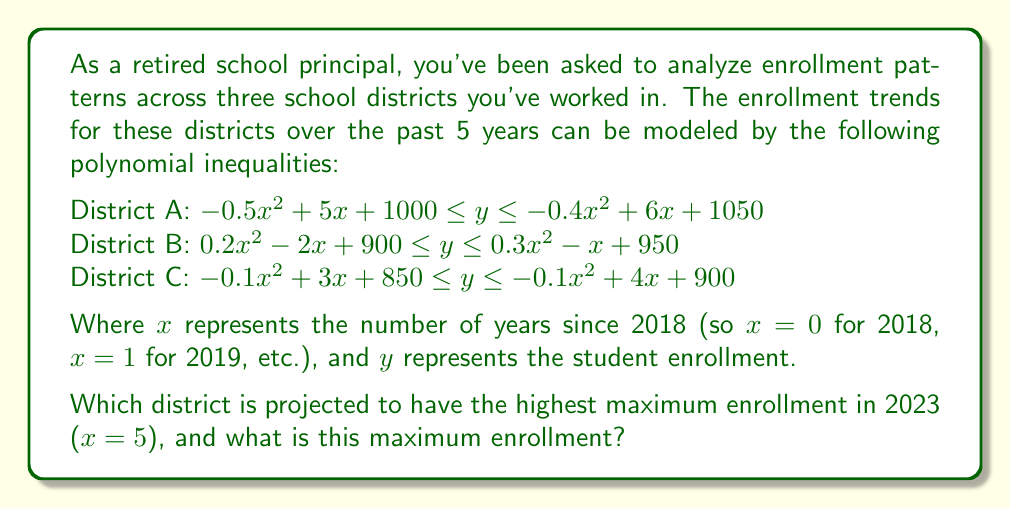Could you help me with this problem? To solve this problem, we need to evaluate the upper bound of each inequality at $x = 5$, as this will give us the maximum possible enrollment for each district in 2023.

For District A:
Upper bound: $y = -0.4x^2 + 6x + 1050$
At $x = 5$: $y = -0.4(5)^2 + 6(5) + 1050 = -10 + 30 + 1050 = 1070$

For District B:
Upper bound: $y = 0.3x^2 - x + 950$
At $x = 5$: $y = 0.3(5)^2 - 5 + 950 = 7.5 - 5 + 950 = 952.5$

For District C:
Upper bound: $y = -0.1x^2 + 4x + 900$
At $x = 5$: $y = -0.1(5)^2 + 4(5) + 900 = -2.5 + 20 + 900 = 917.5$

Comparing these results:
District A: 1070
District B: 952.5
District C: 917.5

We can see that District A has the highest projected maximum enrollment in 2023.
Answer: District A is projected to have the highest maximum enrollment in 2023, with a maximum of 1070 students. 